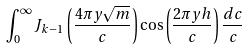<formula> <loc_0><loc_0><loc_500><loc_500>\int _ { 0 } ^ { \infty } J _ { k - 1 } \left ( \frac { 4 \pi y \sqrt { m } } { c } \right ) \cos \left ( \frac { 2 \pi y h } { c } \right ) \frac { d c } { c }</formula> 